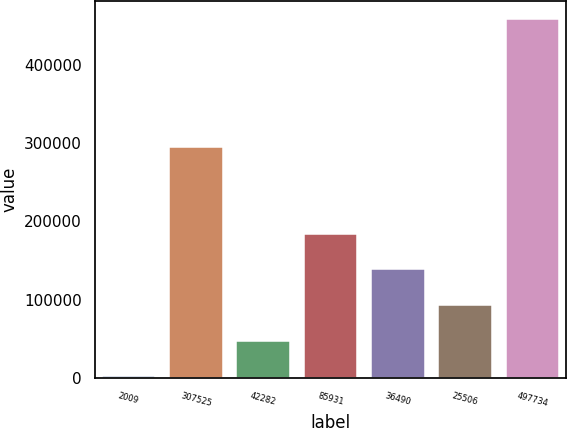Convert chart to OTSL. <chart><loc_0><loc_0><loc_500><loc_500><bar_chart><fcel>2009<fcel>307525<fcel>42282<fcel>85931<fcel>36490<fcel>25506<fcel>497734<nl><fcel>2008<fcel>294699<fcel>47576.4<fcel>184282<fcel>138713<fcel>93144.8<fcel>457692<nl></chart> 